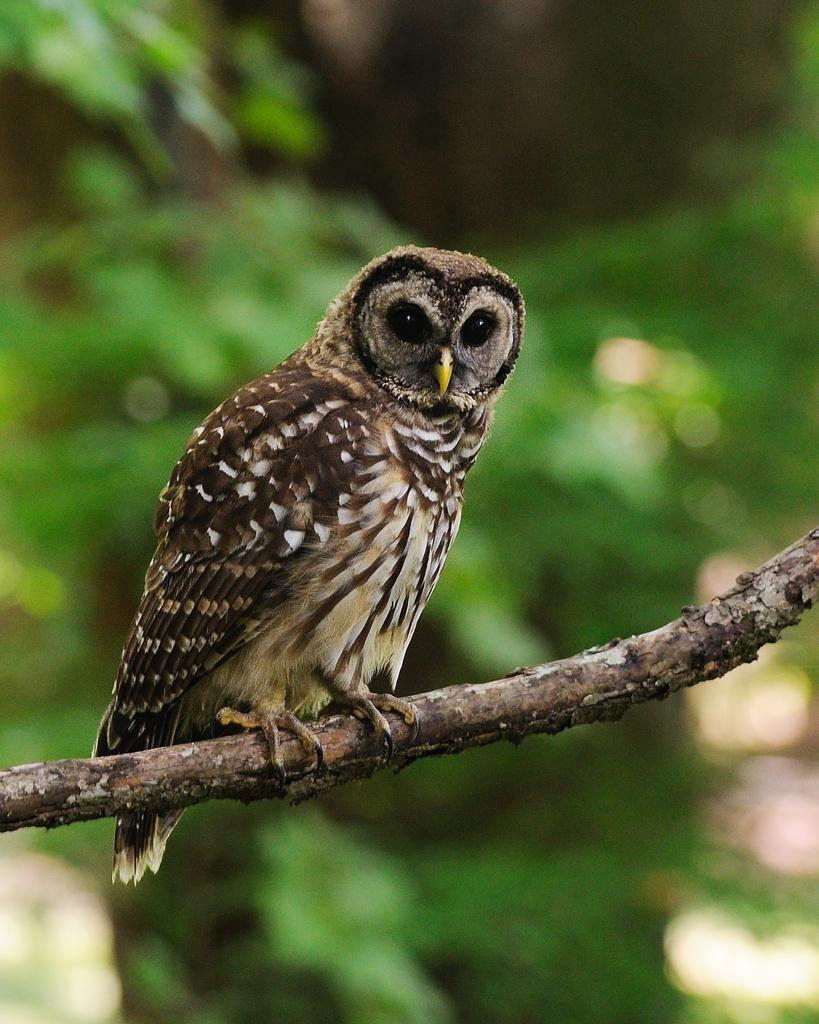What animal is featured in the image? There is an owl in the image. Where is the owl sitting? The owl is sitting on a stem. What can be seen in the background of the image? There are trees in the background of the image. How would you describe the background of the image? The background of the image is blurred. How many dolls are sitting next to the owl in the image? There are no dolls present in the image; it features an owl sitting on a stem with trees in the background. 